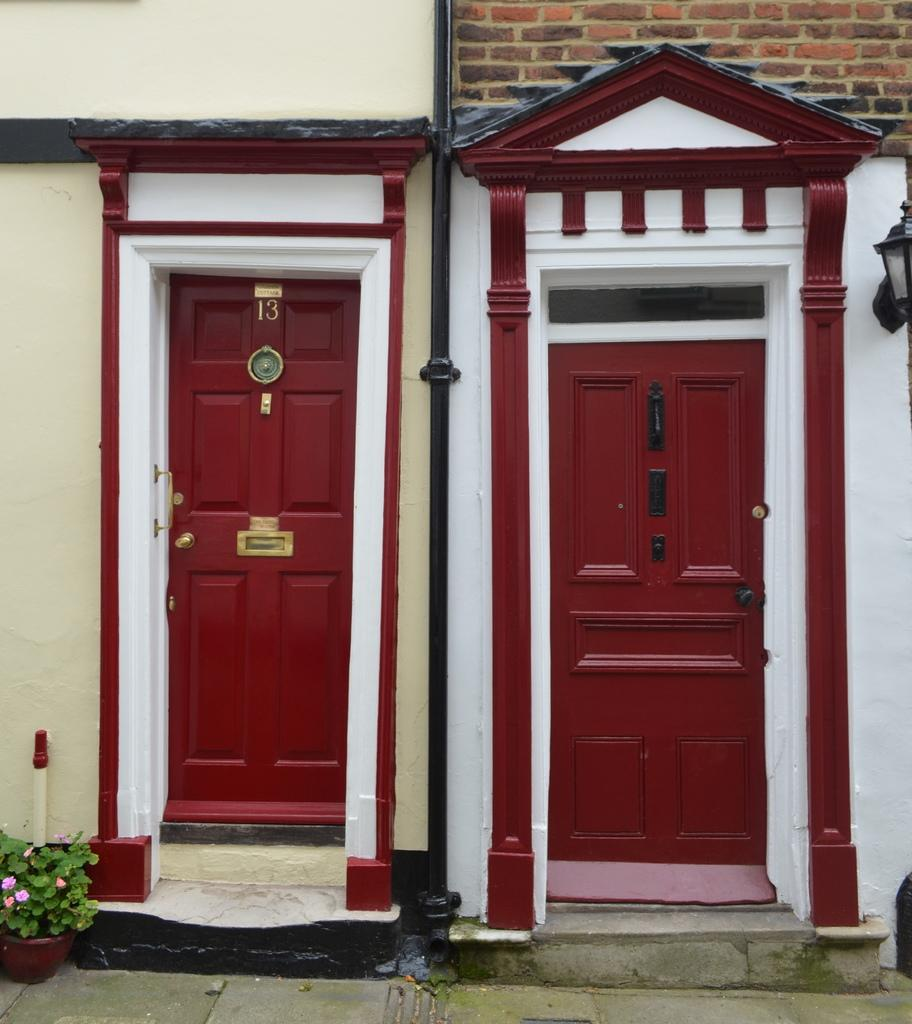What type of structures can be seen in the image? There are doors and walls in the image. Can you describe any other elements in the image? There is a pipe, a plant, and a lantern lamp in the image. What might be the purpose of the pipe in the image? The purpose of the pipe in the image is not specified, but it could be part of a plumbing or ventilation system. What type of lighting is present in the image? A lantern lamp provides lighting in the image. Are there any other objects in the image that are not specified? Yes, there are unspecified objects in the image. What type of reaction can be seen in the cemetery in the image? There is no cemetery present in the image, and therefore no reaction can be observed. 